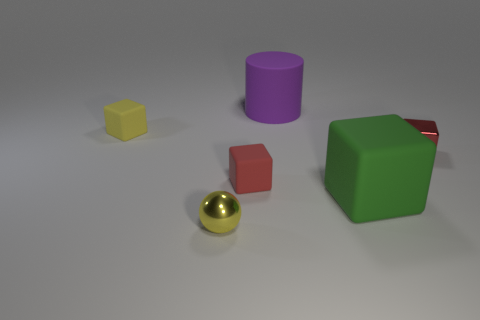Subtract all rubber blocks. How many blocks are left? 1 Subtract all green cubes. How many cubes are left? 3 Add 3 purple rubber objects. How many objects exist? 9 Subtract all gray blocks. Subtract all green cylinders. How many blocks are left? 4 Subtract all balls. How many objects are left? 5 Add 3 tiny red matte things. How many tiny red matte things exist? 4 Subtract 0 red cylinders. How many objects are left? 6 Subtract all red metallic things. Subtract all large cylinders. How many objects are left? 4 Add 6 small metal things. How many small metal things are left? 8 